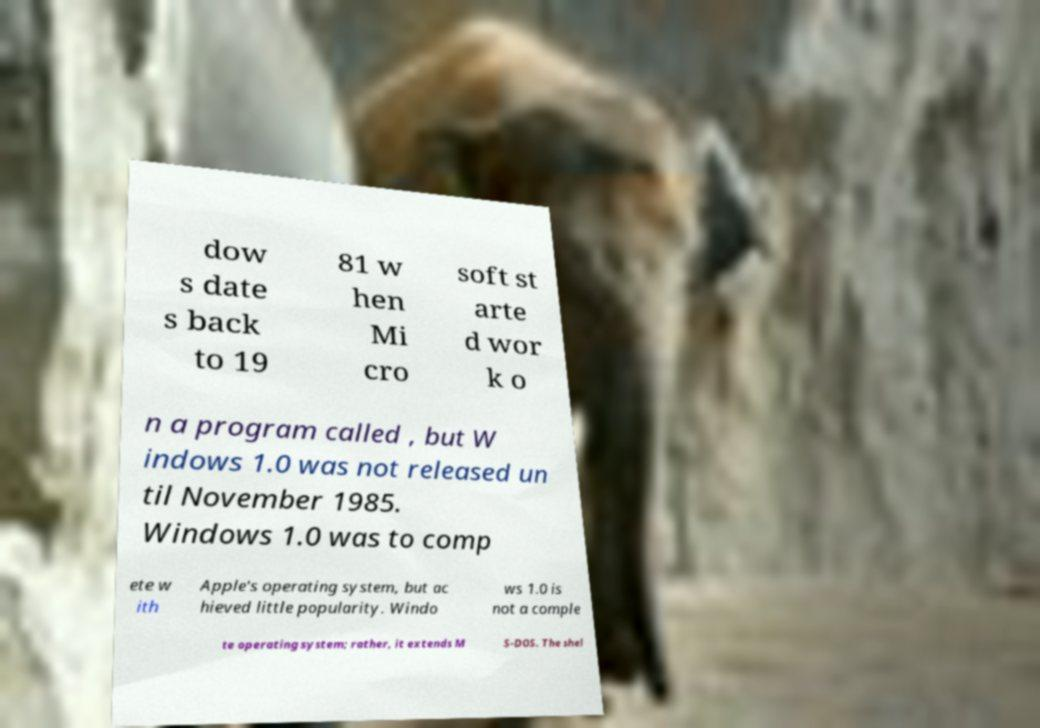Can you read and provide the text displayed in the image?This photo seems to have some interesting text. Can you extract and type it out for me? dow s date s back to 19 81 w hen Mi cro soft st arte d wor k o n a program called , but W indows 1.0 was not released un til November 1985. Windows 1.0 was to comp ete w ith Apple's operating system, but ac hieved little popularity. Windo ws 1.0 is not a comple te operating system; rather, it extends M S-DOS. The shel 